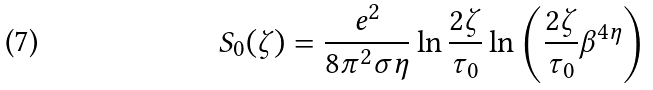Convert formula to latex. <formula><loc_0><loc_0><loc_500><loc_500>S _ { 0 } ( \zeta ) = \frac { e ^ { 2 } } { 8 \pi ^ { 2 } \sigma \eta } \ln \frac { 2 \zeta } { \tau _ { 0 } } \ln \left ( \frac { 2 \zeta } { \tau _ { 0 } } \beta ^ { 4 \eta } \right )</formula> 